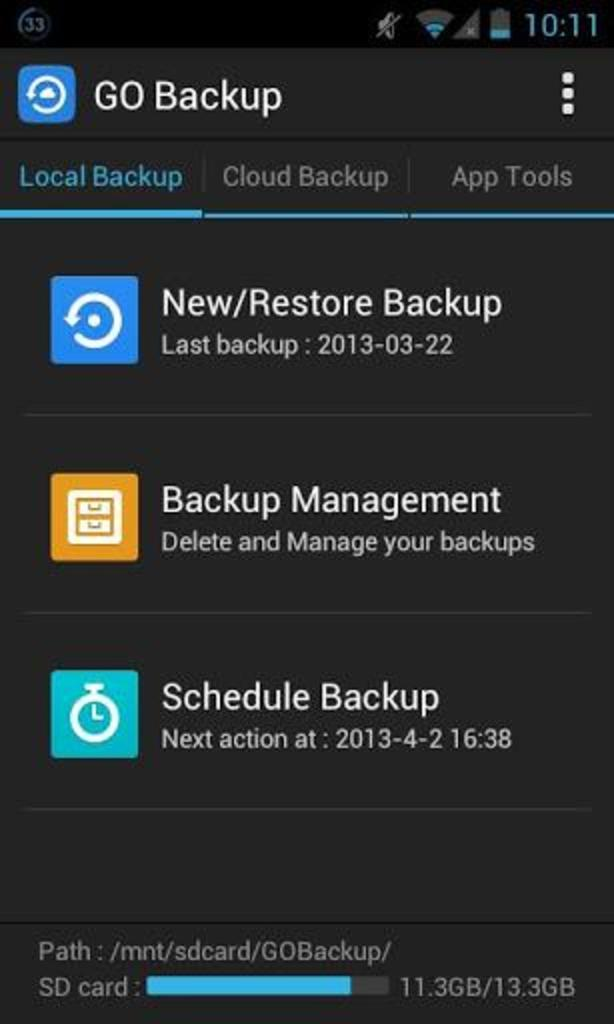Provide a one-sentence caption for the provided image. A screenshot on a phone of the last backup, dated march 22, 2013. 